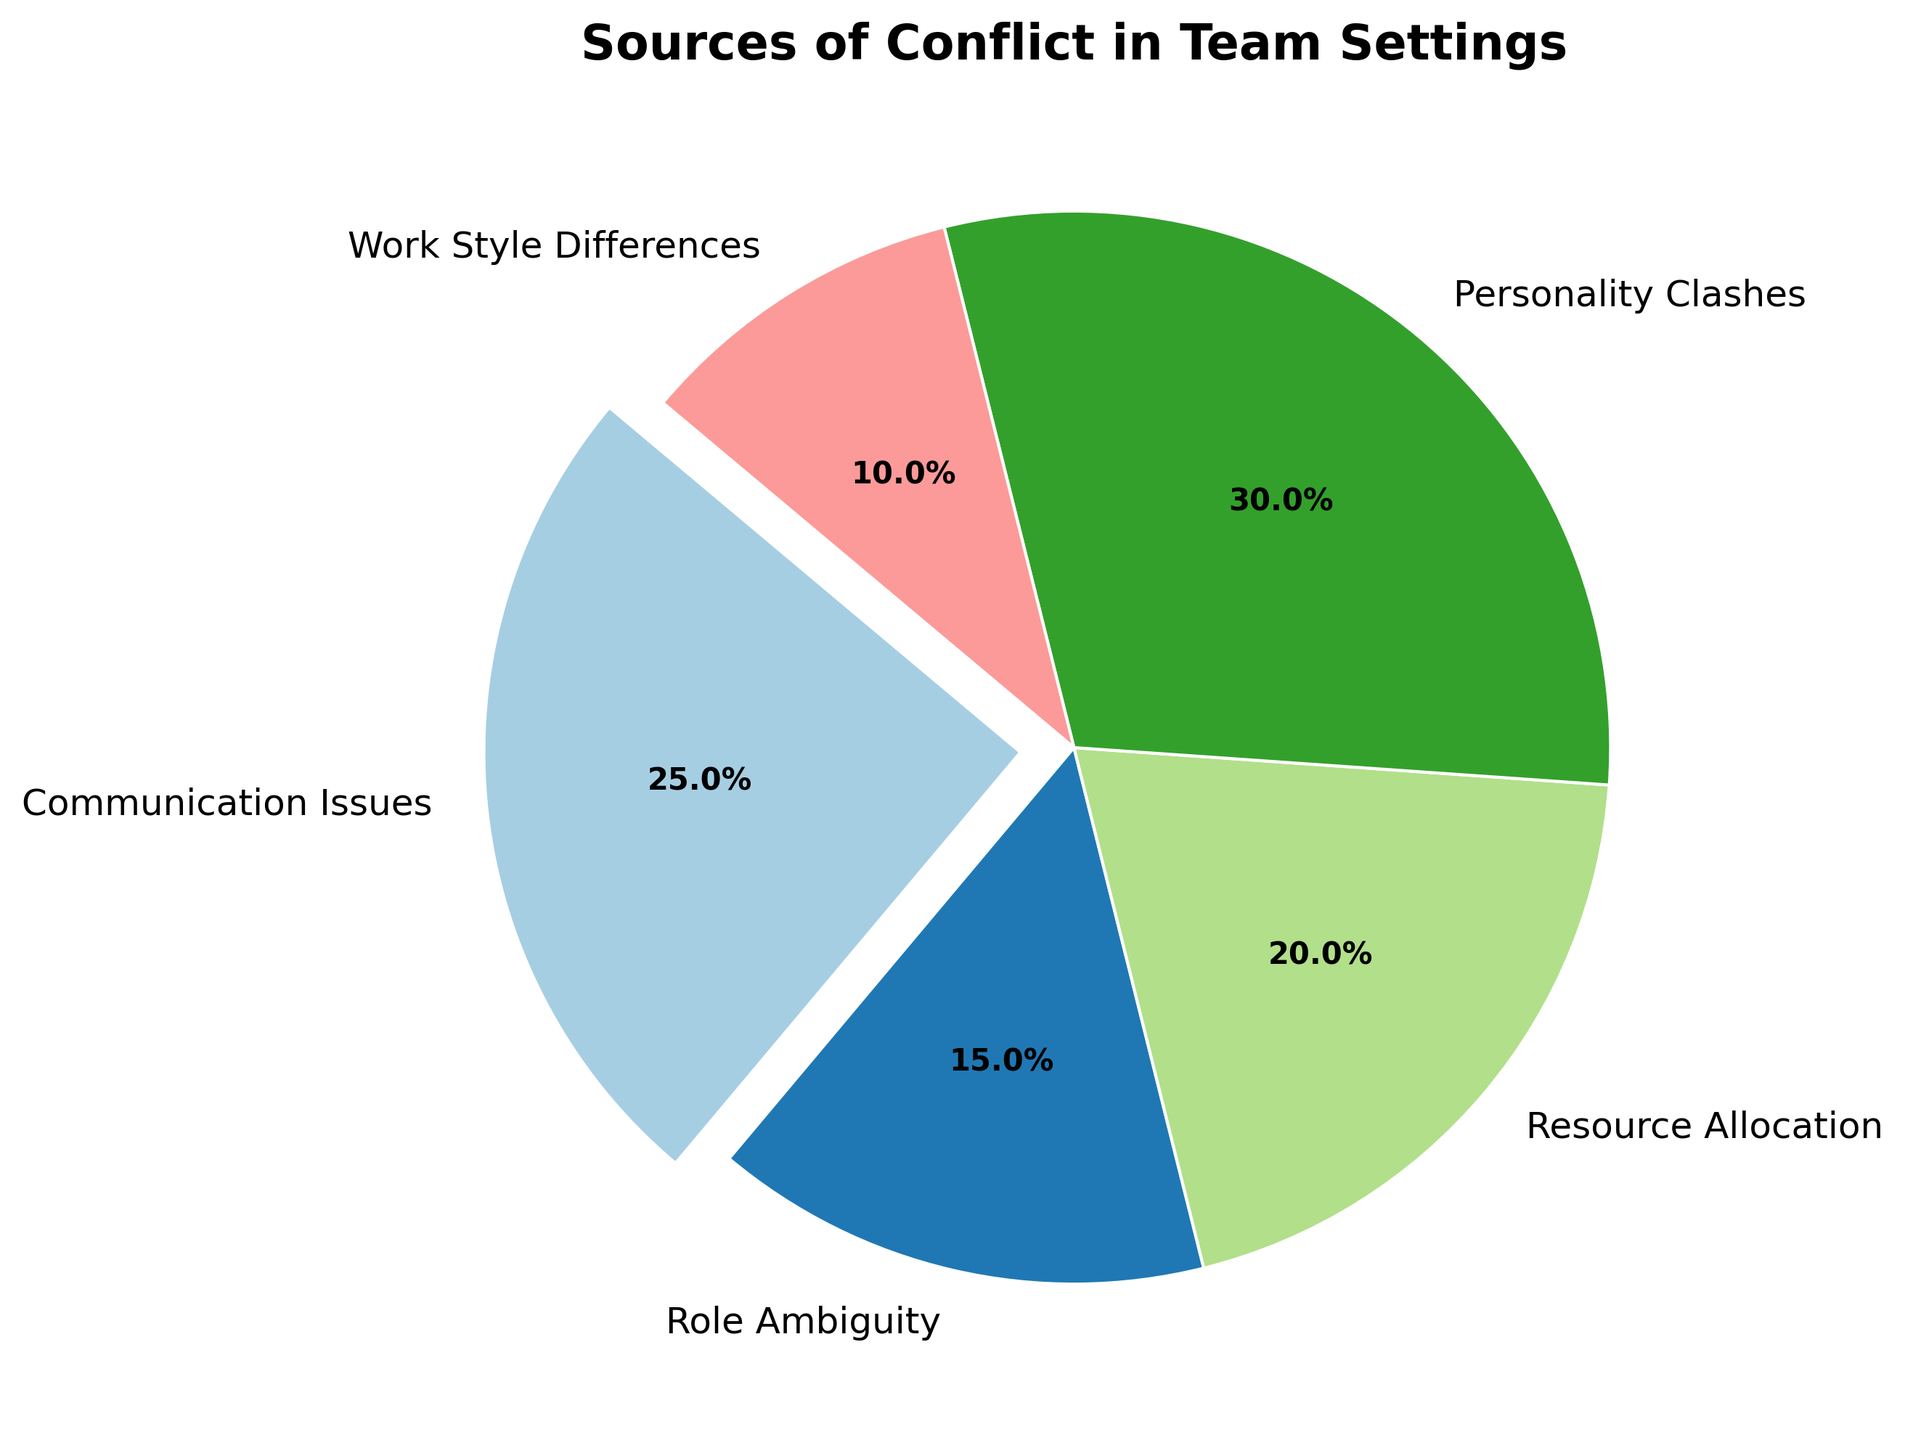What is the largest source of conflict in team settings? The largest source of conflict can be identified by the largest slice in the pie chart, which in this case is labeled as "Personality Clashes" contributing 30%.
Answer: Personality Clashes Which category contributes 20% to the sources of conflict? By reading the labels on the pie chart, the category that contributes exactly 20% is "Resource Allocation".
Answer: Resource Allocation How much larger in percentage is "Personality Clashes" compared to "Communication Issues"? "Personality Clashes" is 30%, and "Communication Issues" is 25%. To find how much larger, we subtract the percentage of "Communication Issues" from the percentage of "Personality Clashes": 30% - 25% = 5%.
Answer: 5% Sum the percentages of "Role Ambiguity" and "Work Style Differences". What value do you get? The percentages are given as 15% for "Role Ambiguity" and 10% for "Work Style Differences". Summing these together: 15% + 10% = 25%.
Answer: 25% Are "Resource Allocation" and "Work Style Differences" combined larger or smaller than "Personality Clashes"? The combined percentage for "Resource Allocation" (20%) and "Work Style Differences" (10%) is 20% + 10% = 30%. "Personality Clashes" is also 30%, meaning they are equal.
Answer: Equal If "Work Style Differences" were to double, what would its new percentage be? Would it then become the largest source of conflict? The current percentage of "Work Style Differences" is 10%. Doubling this, we get 10% * 2 = 20%. It would not become the largest source since "Personality Clashes" is at 30%.
Answer: No Which slice of the pie chart is highlighted or exploded? Observing the visual layout, it's evident that "Communication Issues" is the exploded slice. This is usually done to emphasize a particular category.
Answer: Communication Issues What are the top three sources of conflict in team settings based on their percentages? By examining the pie chart, the top three sources are "Personality Clashes" (30%), "Communication Issues" (25%), and "Resource Allocation" (20%) when sorted in descending order.
Answer: Personality Clashes, Communication Issues, Resource Allocation What is the combined percentage of issues related to both "Role Ambiguity" and "Personality Clashes"? The percentages are 15% for "Role Ambiguity" and 30% for "Personality Clashes". Adding these together, the combined percentage is 15% + 30% = 45%.
Answer: 45% Compare the visual sizes of the slices. Which is smaller, "Work Style Differences" or "Role Ambiguity"? "Work Style Differences" is 10%, and "Role Ambiguity" is 15%. The slice representing "Work Style Differences" is visually smaller than the slice for "Role Ambiguity".
Answer: Work Style Differences 